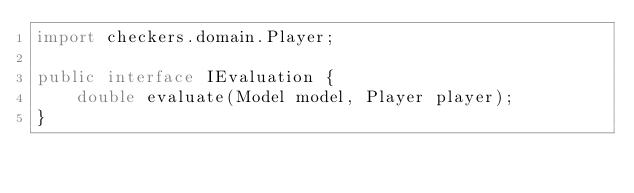Convert code to text. <code><loc_0><loc_0><loc_500><loc_500><_Java_>import checkers.domain.Player;

public interface IEvaluation {
	double evaluate(Model model, Player player);
}
</code> 